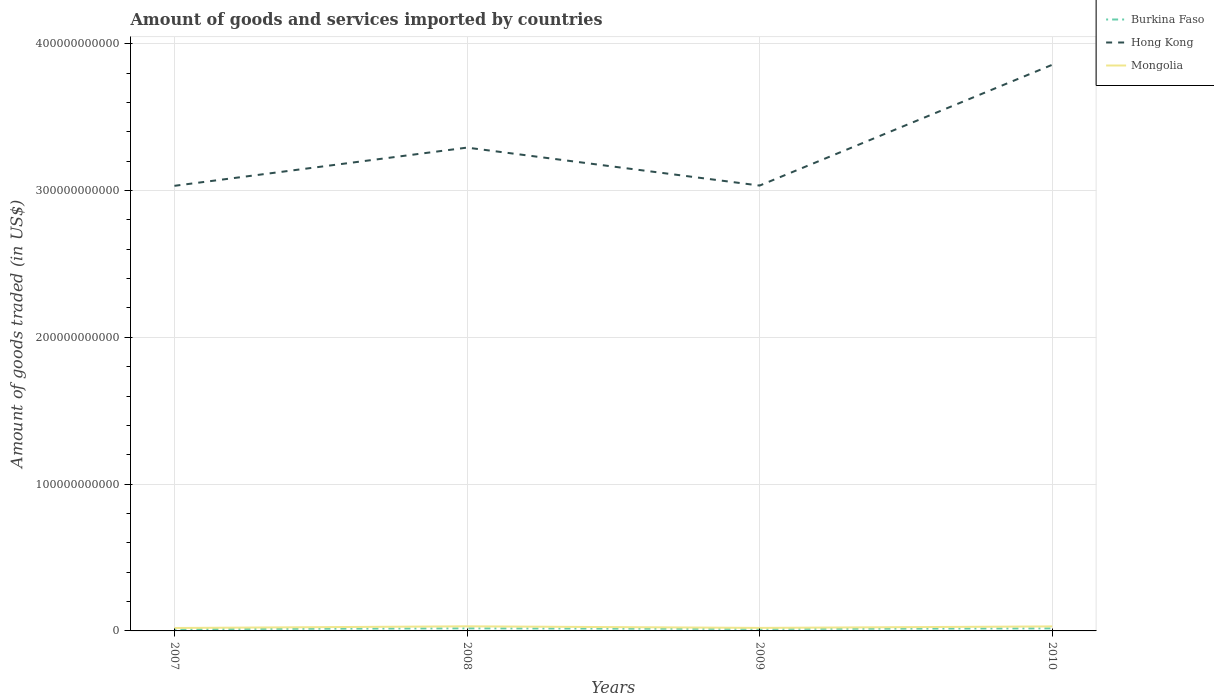Is the number of lines equal to the number of legend labels?
Keep it short and to the point. Yes. Across all years, what is the maximum total amount of goods and services imported in Mongolia?
Provide a short and direct response. 2.00e+09. What is the total total amount of goods and services imported in Hong Kong in the graph?
Provide a short and direct response. -8.24e+1. What is the difference between the highest and the second highest total amount of goods and services imported in Mongolia?
Offer a terse response. 1.13e+09. Is the total amount of goods and services imported in Burkina Faso strictly greater than the total amount of goods and services imported in Mongolia over the years?
Offer a very short reply. Yes. How many lines are there?
Provide a short and direct response. 3. How many years are there in the graph?
Your answer should be very brief. 4. What is the difference between two consecutive major ticks on the Y-axis?
Your answer should be very brief. 1.00e+11. Are the values on the major ticks of Y-axis written in scientific E-notation?
Ensure brevity in your answer.  No. Does the graph contain grids?
Your answer should be compact. Yes. How many legend labels are there?
Provide a succinct answer. 3. How are the legend labels stacked?
Provide a short and direct response. Vertical. What is the title of the graph?
Ensure brevity in your answer.  Amount of goods and services imported by countries. What is the label or title of the Y-axis?
Make the answer very short. Amount of goods traded (in US$). What is the Amount of goods traded (in US$) in Burkina Faso in 2007?
Keep it short and to the point. 1.25e+09. What is the Amount of goods traded (in US$) of Hong Kong in 2007?
Offer a very short reply. 3.03e+11. What is the Amount of goods traded (in US$) in Mongolia in 2007?
Provide a succinct answer. 2.00e+09. What is the Amount of goods traded (in US$) of Burkina Faso in 2008?
Your answer should be compact. 1.75e+09. What is the Amount of goods traded (in US$) in Hong Kong in 2008?
Your answer should be compact. 3.29e+11. What is the Amount of goods traded (in US$) in Mongolia in 2008?
Provide a succinct answer. 3.14e+09. What is the Amount of goods traded (in US$) in Burkina Faso in 2009?
Make the answer very short. 1.38e+09. What is the Amount of goods traded (in US$) of Hong Kong in 2009?
Offer a terse response. 3.03e+11. What is the Amount of goods traded (in US$) in Mongolia in 2009?
Your answer should be compact. 2.06e+09. What is the Amount of goods traded (in US$) in Burkina Faso in 2010?
Ensure brevity in your answer.  1.72e+09. What is the Amount of goods traded (in US$) of Hong Kong in 2010?
Your answer should be very brief. 3.86e+11. What is the Amount of goods traded (in US$) of Mongolia in 2010?
Your response must be concise. 3.08e+09. Across all years, what is the maximum Amount of goods traded (in US$) in Burkina Faso?
Your answer should be compact. 1.75e+09. Across all years, what is the maximum Amount of goods traded (in US$) in Hong Kong?
Provide a short and direct response. 3.86e+11. Across all years, what is the maximum Amount of goods traded (in US$) of Mongolia?
Offer a terse response. 3.14e+09. Across all years, what is the minimum Amount of goods traded (in US$) in Burkina Faso?
Provide a succinct answer. 1.25e+09. Across all years, what is the minimum Amount of goods traded (in US$) of Hong Kong?
Offer a terse response. 3.03e+11. Across all years, what is the minimum Amount of goods traded (in US$) in Mongolia?
Your answer should be compact. 2.00e+09. What is the total Amount of goods traded (in US$) in Burkina Faso in the graph?
Provide a succinct answer. 6.10e+09. What is the total Amount of goods traded (in US$) in Hong Kong in the graph?
Make the answer very short. 1.32e+12. What is the total Amount of goods traded (in US$) in Mongolia in the graph?
Give a very brief answer. 1.03e+1. What is the difference between the Amount of goods traded (in US$) in Burkina Faso in 2007 and that in 2008?
Offer a terse response. -4.92e+08. What is the difference between the Amount of goods traded (in US$) of Hong Kong in 2007 and that in 2008?
Make the answer very short. -2.60e+1. What is the difference between the Amount of goods traded (in US$) of Mongolia in 2007 and that in 2008?
Offer a terse response. -1.13e+09. What is the difference between the Amount of goods traded (in US$) in Burkina Faso in 2007 and that in 2009?
Provide a short and direct response. -1.27e+08. What is the difference between the Amount of goods traded (in US$) of Hong Kong in 2007 and that in 2009?
Your answer should be compact. -1.67e+08. What is the difference between the Amount of goods traded (in US$) in Mongolia in 2007 and that in 2009?
Provide a succinct answer. -5.60e+07. What is the difference between the Amount of goods traded (in US$) of Burkina Faso in 2007 and that in 2010?
Make the answer very short. -4.69e+08. What is the difference between the Amount of goods traded (in US$) in Hong Kong in 2007 and that in 2010?
Your response must be concise. -8.24e+1. What is the difference between the Amount of goods traded (in US$) of Mongolia in 2007 and that in 2010?
Provide a short and direct response. -1.08e+09. What is the difference between the Amount of goods traded (in US$) in Burkina Faso in 2008 and that in 2009?
Your answer should be compact. 3.65e+08. What is the difference between the Amount of goods traded (in US$) of Hong Kong in 2008 and that in 2009?
Your answer should be very brief. 2.59e+1. What is the difference between the Amount of goods traded (in US$) of Mongolia in 2008 and that in 2009?
Keep it short and to the point. 1.08e+09. What is the difference between the Amount of goods traded (in US$) in Burkina Faso in 2008 and that in 2010?
Offer a terse response. 2.26e+07. What is the difference between the Amount of goods traded (in US$) in Hong Kong in 2008 and that in 2010?
Offer a very short reply. -5.64e+1. What is the difference between the Amount of goods traded (in US$) in Mongolia in 2008 and that in 2010?
Offer a terse response. 5.81e+07. What is the difference between the Amount of goods traded (in US$) in Burkina Faso in 2009 and that in 2010?
Provide a short and direct response. -3.42e+08. What is the difference between the Amount of goods traded (in US$) of Hong Kong in 2009 and that in 2010?
Your answer should be very brief. -8.23e+1. What is the difference between the Amount of goods traded (in US$) in Mongolia in 2009 and that in 2010?
Give a very brief answer. -1.02e+09. What is the difference between the Amount of goods traded (in US$) in Burkina Faso in 2007 and the Amount of goods traded (in US$) in Hong Kong in 2008?
Make the answer very short. -3.28e+11. What is the difference between the Amount of goods traded (in US$) in Burkina Faso in 2007 and the Amount of goods traded (in US$) in Mongolia in 2008?
Offer a terse response. -1.88e+09. What is the difference between the Amount of goods traded (in US$) in Hong Kong in 2007 and the Amount of goods traded (in US$) in Mongolia in 2008?
Offer a very short reply. 3.00e+11. What is the difference between the Amount of goods traded (in US$) of Burkina Faso in 2007 and the Amount of goods traded (in US$) of Hong Kong in 2009?
Make the answer very short. -3.02e+11. What is the difference between the Amount of goods traded (in US$) in Burkina Faso in 2007 and the Amount of goods traded (in US$) in Mongolia in 2009?
Your answer should be very brief. -8.05e+08. What is the difference between the Amount of goods traded (in US$) of Hong Kong in 2007 and the Amount of goods traded (in US$) of Mongolia in 2009?
Offer a very short reply. 3.01e+11. What is the difference between the Amount of goods traded (in US$) in Burkina Faso in 2007 and the Amount of goods traded (in US$) in Hong Kong in 2010?
Offer a terse response. -3.84e+11. What is the difference between the Amount of goods traded (in US$) in Burkina Faso in 2007 and the Amount of goods traded (in US$) in Mongolia in 2010?
Your answer should be very brief. -1.83e+09. What is the difference between the Amount of goods traded (in US$) in Hong Kong in 2007 and the Amount of goods traded (in US$) in Mongolia in 2010?
Offer a very short reply. 3.00e+11. What is the difference between the Amount of goods traded (in US$) in Burkina Faso in 2008 and the Amount of goods traded (in US$) in Hong Kong in 2009?
Make the answer very short. -3.02e+11. What is the difference between the Amount of goods traded (in US$) in Burkina Faso in 2008 and the Amount of goods traded (in US$) in Mongolia in 2009?
Your response must be concise. -3.13e+08. What is the difference between the Amount of goods traded (in US$) in Hong Kong in 2008 and the Amount of goods traded (in US$) in Mongolia in 2009?
Provide a succinct answer. 3.27e+11. What is the difference between the Amount of goods traded (in US$) of Burkina Faso in 2008 and the Amount of goods traded (in US$) of Hong Kong in 2010?
Give a very brief answer. -3.84e+11. What is the difference between the Amount of goods traded (in US$) in Burkina Faso in 2008 and the Amount of goods traded (in US$) in Mongolia in 2010?
Offer a terse response. -1.33e+09. What is the difference between the Amount of goods traded (in US$) in Hong Kong in 2008 and the Amount of goods traded (in US$) in Mongolia in 2010?
Provide a succinct answer. 3.26e+11. What is the difference between the Amount of goods traded (in US$) in Burkina Faso in 2009 and the Amount of goods traded (in US$) in Hong Kong in 2010?
Give a very brief answer. -3.84e+11. What is the difference between the Amount of goods traded (in US$) in Burkina Faso in 2009 and the Amount of goods traded (in US$) in Mongolia in 2010?
Provide a short and direct response. -1.70e+09. What is the difference between the Amount of goods traded (in US$) in Hong Kong in 2009 and the Amount of goods traded (in US$) in Mongolia in 2010?
Make the answer very short. 3.00e+11. What is the average Amount of goods traded (in US$) of Burkina Faso per year?
Offer a very short reply. 1.53e+09. What is the average Amount of goods traded (in US$) of Hong Kong per year?
Provide a succinct answer. 3.30e+11. What is the average Amount of goods traded (in US$) in Mongolia per year?
Provide a short and direct response. 2.57e+09. In the year 2007, what is the difference between the Amount of goods traded (in US$) in Burkina Faso and Amount of goods traded (in US$) in Hong Kong?
Provide a short and direct response. -3.02e+11. In the year 2007, what is the difference between the Amount of goods traded (in US$) of Burkina Faso and Amount of goods traded (in US$) of Mongolia?
Your response must be concise. -7.49e+08. In the year 2007, what is the difference between the Amount of goods traded (in US$) of Hong Kong and Amount of goods traded (in US$) of Mongolia?
Offer a very short reply. 3.01e+11. In the year 2008, what is the difference between the Amount of goods traded (in US$) in Burkina Faso and Amount of goods traded (in US$) in Hong Kong?
Provide a succinct answer. -3.27e+11. In the year 2008, what is the difference between the Amount of goods traded (in US$) of Burkina Faso and Amount of goods traded (in US$) of Mongolia?
Ensure brevity in your answer.  -1.39e+09. In the year 2008, what is the difference between the Amount of goods traded (in US$) in Hong Kong and Amount of goods traded (in US$) in Mongolia?
Ensure brevity in your answer.  3.26e+11. In the year 2009, what is the difference between the Amount of goods traded (in US$) of Burkina Faso and Amount of goods traded (in US$) of Hong Kong?
Provide a succinct answer. -3.02e+11. In the year 2009, what is the difference between the Amount of goods traded (in US$) of Burkina Faso and Amount of goods traded (in US$) of Mongolia?
Make the answer very short. -6.78e+08. In the year 2009, what is the difference between the Amount of goods traded (in US$) of Hong Kong and Amount of goods traded (in US$) of Mongolia?
Your answer should be compact. 3.01e+11. In the year 2010, what is the difference between the Amount of goods traded (in US$) in Burkina Faso and Amount of goods traded (in US$) in Hong Kong?
Your answer should be compact. -3.84e+11. In the year 2010, what is the difference between the Amount of goods traded (in US$) in Burkina Faso and Amount of goods traded (in US$) in Mongolia?
Provide a succinct answer. -1.36e+09. In the year 2010, what is the difference between the Amount of goods traded (in US$) in Hong Kong and Amount of goods traded (in US$) in Mongolia?
Provide a succinct answer. 3.83e+11. What is the ratio of the Amount of goods traded (in US$) in Burkina Faso in 2007 to that in 2008?
Offer a very short reply. 0.72. What is the ratio of the Amount of goods traded (in US$) of Hong Kong in 2007 to that in 2008?
Your answer should be very brief. 0.92. What is the ratio of the Amount of goods traded (in US$) of Mongolia in 2007 to that in 2008?
Give a very brief answer. 0.64. What is the ratio of the Amount of goods traded (in US$) in Burkina Faso in 2007 to that in 2009?
Offer a very short reply. 0.91. What is the ratio of the Amount of goods traded (in US$) in Mongolia in 2007 to that in 2009?
Your answer should be compact. 0.97. What is the ratio of the Amount of goods traded (in US$) of Burkina Faso in 2007 to that in 2010?
Your answer should be compact. 0.73. What is the ratio of the Amount of goods traded (in US$) of Hong Kong in 2007 to that in 2010?
Offer a very short reply. 0.79. What is the ratio of the Amount of goods traded (in US$) of Mongolia in 2007 to that in 2010?
Offer a terse response. 0.65. What is the ratio of the Amount of goods traded (in US$) in Burkina Faso in 2008 to that in 2009?
Your answer should be compact. 1.26. What is the ratio of the Amount of goods traded (in US$) of Hong Kong in 2008 to that in 2009?
Offer a terse response. 1.09. What is the ratio of the Amount of goods traded (in US$) in Mongolia in 2008 to that in 2009?
Offer a terse response. 1.52. What is the ratio of the Amount of goods traded (in US$) of Burkina Faso in 2008 to that in 2010?
Give a very brief answer. 1.01. What is the ratio of the Amount of goods traded (in US$) of Hong Kong in 2008 to that in 2010?
Offer a terse response. 0.85. What is the ratio of the Amount of goods traded (in US$) in Mongolia in 2008 to that in 2010?
Offer a terse response. 1.02. What is the ratio of the Amount of goods traded (in US$) of Burkina Faso in 2009 to that in 2010?
Offer a terse response. 0.8. What is the ratio of the Amount of goods traded (in US$) of Hong Kong in 2009 to that in 2010?
Offer a terse response. 0.79. What is the ratio of the Amount of goods traded (in US$) of Mongolia in 2009 to that in 2010?
Offer a very short reply. 0.67. What is the difference between the highest and the second highest Amount of goods traded (in US$) in Burkina Faso?
Keep it short and to the point. 2.26e+07. What is the difference between the highest and the second highest Amount of goods traded (in US$) of Hong Kong?
Your answer should be very brief. 5.64e+1. What is the difference between the highest and the second highest Amount of goods traded (in US$) of Mongolia?
Your answer should be very brief. 5.81e+07. What is the difference between the highest and the lowest Amount of goods traded (in US$) in Burkina Faso?
Offer a terse response. 4.92e+08. What is the difference between the highest and the lowest Amount of goods traded (in US$) in Hong Kong?
Keep it short and to the point. 8.24e+1. What is the difference between the highest and the lowest Amount of goods traded (in US$) in Mongolia?
Your answer should be very brief. 1.13e+09. 